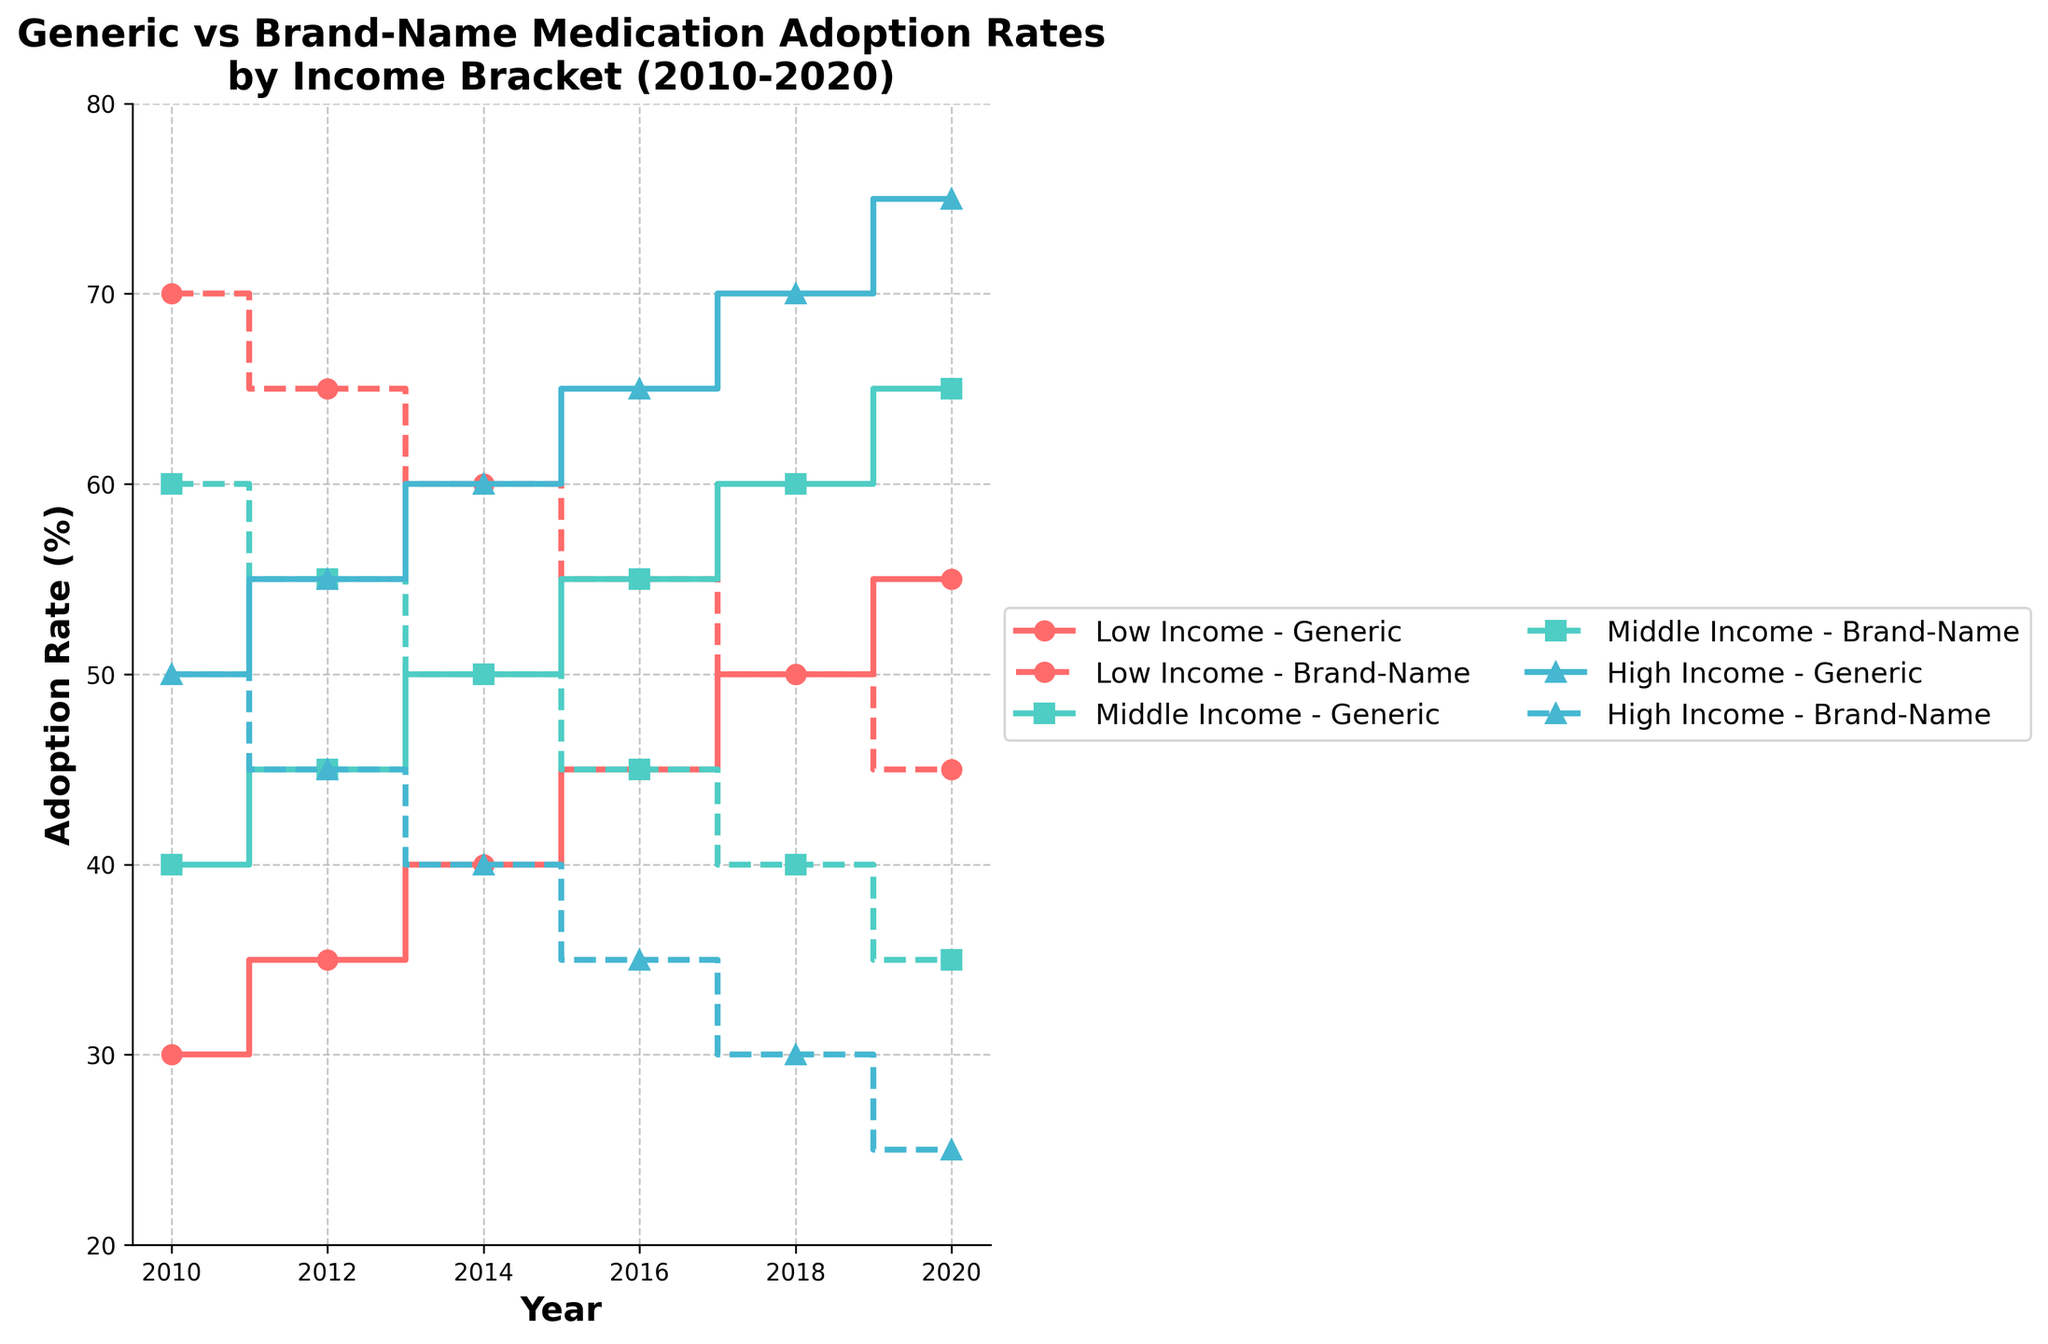What is the title of the figure? The title of the figure is located at the top and is usually the largest text, which outlines what the plot represents.
Answer: Generic vs Brand-Name Medication Adoption Rates by Income Bracket (2010-2020) What does the x-axis represent? The x-axis typically represents the independent variable in a plot. In this case, the x-axis runs horizontally and indicates the years from 2010 to 2020.
Answer: Year What's the adoption rate of generic medications for low-income individuals in 2020? To find this, look for the "Low Income" group on the plot. Follow the generic step line to the year 2020 on the x-axis and read the corresponding value on the y-axis.
Answer: 55% Which income bracket shows the highest adoption rate of brand-name medications in 2016? Find the year 2016 on the x-axis and compare the heights of the brand-name step lines for each income bracket. The highest position on the y-axis indicates the highest rate.
Answer: Low Income Between which years did the "Middle Income" bracket see the greatest increase in generic medication adoption? Follow the generic medication step line for the "Middle Income" bracket. Observe the differences between consecutive steps from 2010 to 2020 and identify the largest increase.
Answer: 2010 to 2012 Calculate the average adoption rate of brand-name medications for the "High Income" group over the decade. Add up the brand-name adoption rates for the "High Income" group across all years and then divide by the number of data points (6).
Answer: (50 + 45 + 40 + 35 + 30 + 25) / 6 = 37.5% Which year shows an equal adoption rate between generic and brand-name medications for the "Low Income" bracket? Look at the "Low Income" bracket lines for the year where both the generic and brand-name step lines intersect at the same value on the y-axis.
Answer: 2018 How does the adoption trend for generic medications in "High Income" compare to "Low Income" from 2010 to 2020? Compare the angles and the overall increase in the step lines for generic medications in both "High Income" and "Low Income" groups from 2010 to 2020.
Answer: High Income rises faster What's the difference in brand-name medication adoption rates between "Low Income" and "Middle Income" in 2014? Locate the brand-name adoption rates for both "Low Income" and "Middle Income" groups in 2014, then subtract the "Middle Income" value from the "Low Income" value.
Answer: 60% - 50% = 10% 